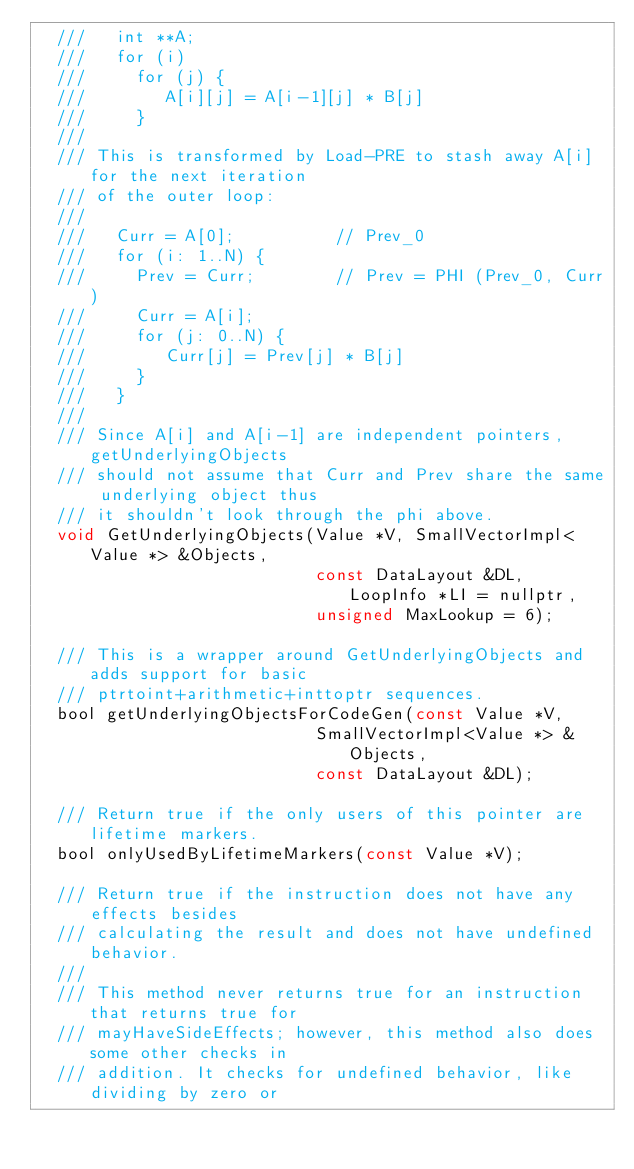<code> <loc_0><loc_0><loc_500><loc_500><_C_>  ///   int **A;
  ///   for (i)
  ///     for (j) {
  ///        A[i][j] = A[i-1][j] * B[j]
  ///     }
  ///
  /// This is transformed by Load-PRE to stash away A[i] for the next iteration
  /// of the outer loop:
  ///
  ///   Curr = A[0];          // Prev_0
  ///   for (i: 1..N) {
  ///     Prev = Curr;        // Prev = PHI (Prev_0, Curr)
  ///     Curr = A[i];
  ///     for (j: 0..N) {
  ///        Curr[j] = Prev[j] * B[j]
  ///     }
  ///   }
  ///
  /// Since A[i] and A[i-1] are independent pointers, getUnderlyingObjects
  /// should not assume that Curr and Prev share the same underlying object thus
  /// it shouldn't look through the phi above.
  void GetUnderlyingObjects(Value *V, SmallVectorImpl<Value *> &Objects,
                            const DataLayout &DL, LoopInfo *LI = nullptr,
                            unsigned MaxLookup = 6);

  /// This is a wrapper around GetUnderlyingObjects and adds support for basic
  /// ptrtoint+arithmetic+inttoptr sequences.
  bool getUnderlyingObjectsForCodeGen(const Value *V,
                            SmallVectorImpl<Value *> &Objects,
                            const DataLayout &DL);

  /// Return true if the only users of this pointer are lifetime markers.
  bool onlyUsedByLifetimeMarkers(const Value *V);

  /// Return true if the instruction does not have any effects besides
  /// calculating the result and does not have undefined behavior.
  ///
  /// This method never returns true for an instruction that returns true for
  /// mayHaveSideEffects; however, this method also does some other checks in
  /// addition. It checks for undefined behavior, like dividing by zero or</code> 